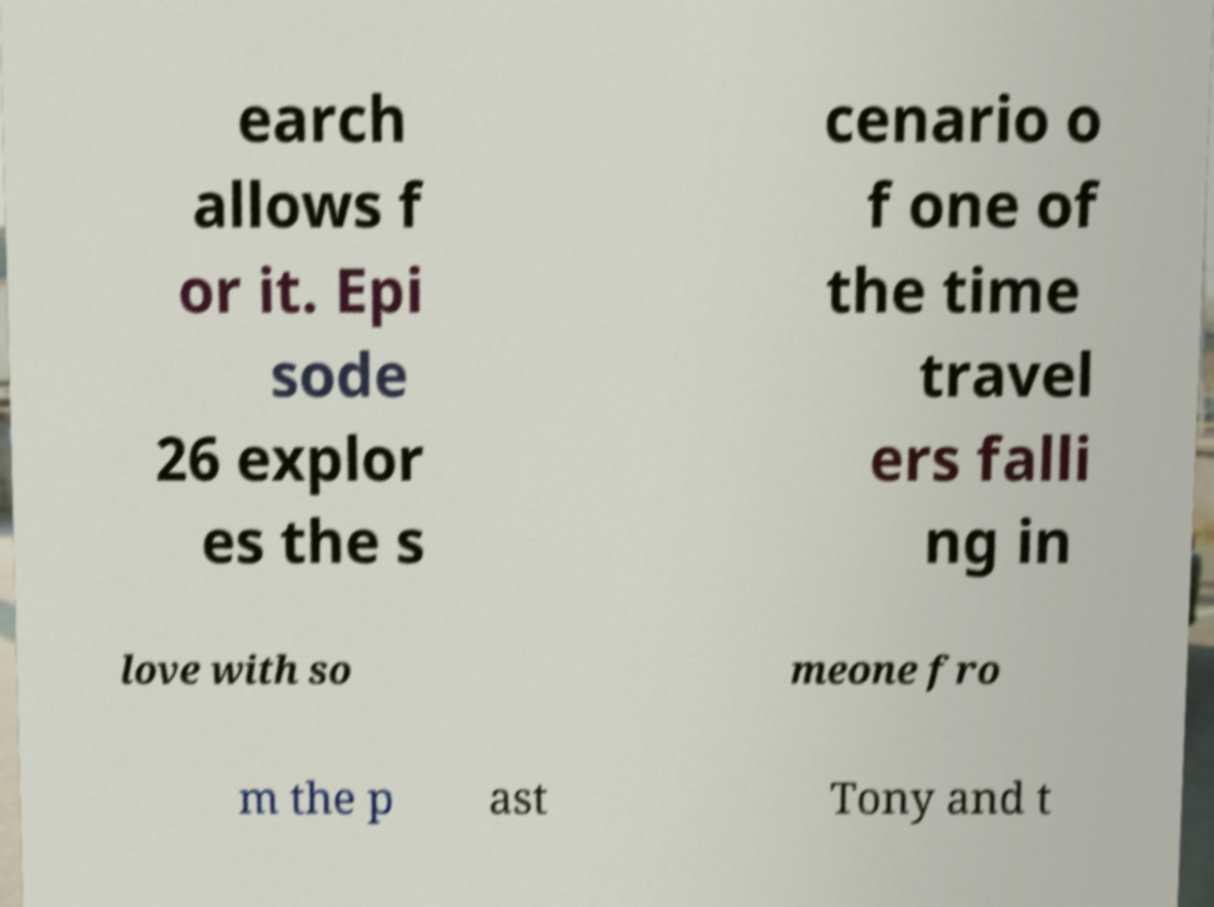What messages or text are displayed in this image? I need them in a readable, typed format. earch allows f or it. Epi sode 26 explor es the s cenario o f one of the time travel ers falli ng in love with so meone fro m the p ast Tony and t 